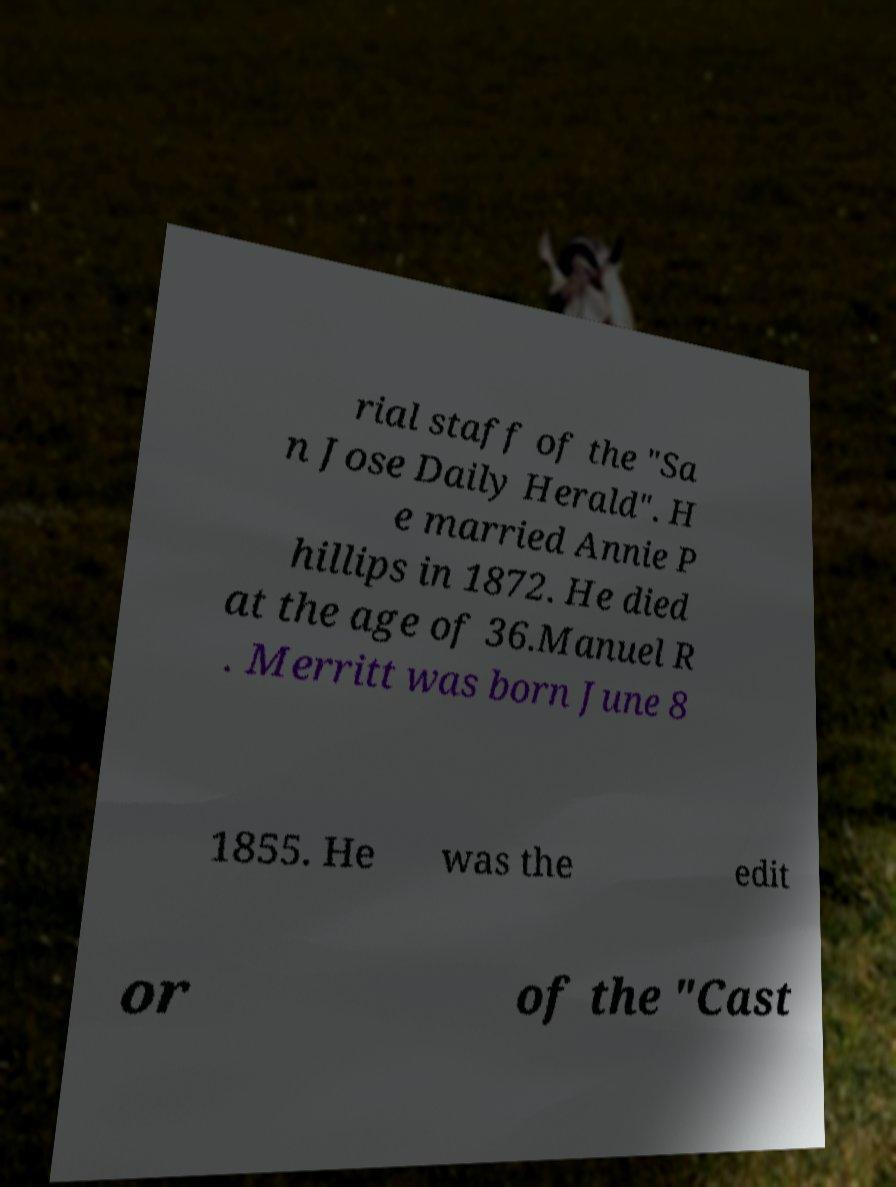I need the written content from this picture converted into text. Can you do that? rial staff of the "Sa n Jose Daily Herald". H e married Annie P hillips in 1872. He died at the age of 36.Manuel R . Merritt was born June 8 1855. He was the edit or of the "Cast 